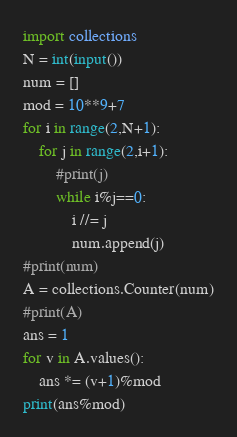Convert code to text. <code><loc_0><loc_0><loc_500><loc_500><_Python_>import collections
N = int(input())
num = []
mod = 10**9+7
for i in range(2,N+1):
    for j in range(2,i+1):
        #print(j)
        while i%j==0:
            i //= j
            num.append(j)
#print(num)
A = collections.Counter(num)
#print(A)
ans = 1
for v in A.values():
    ans *= (v+1)%mod
print(ans%mod)</code> 